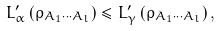Convert formula to latex. <formula><loc_0><loc_0><loc_500><loc_500>L _ { \alpha } ^ { \prime } \left ( \rho _ { A _ { 1 } \cdots A _ { l } } \right ) \leq L _ { \gamma } ^ { \prime } \left ( \rho _ { A _ { 1 } \cdots A _ { l } } \right ) ,</formula> 